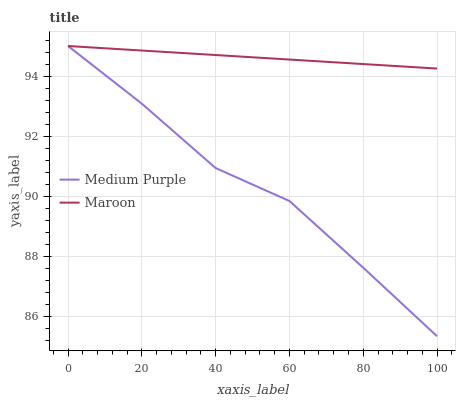Does Medium Purple have the minimum area under the curve?
Answer yes or no. Yes. Does Maroon have the maximum area under the curve?
Answer yes or no. Yes. Does Maroon have the minimum area under the curve?
Answer yes or no. No. Is Maroon the smoothest?
Answer yes or no. Yes. Is Medium Purple the roughest?
Answer yes or no. Yes. Is Maroon the roughest?
Answer yes or no. No. Does Medium Purple have the lowest value?
Answer yes or no. Yes. Does Maroon have the lowest value?
Answer yes or no. No. Does Maroon have the highest value?
Answer yes or no. Yes. Does Maroon intersect Medium Purple?
Answer yes or no. Yes. Is Maroon less than Medium Purple?
Answer yes or no. No. Is Maroon greater than Medium Purple?
Answer yes or no. No. 